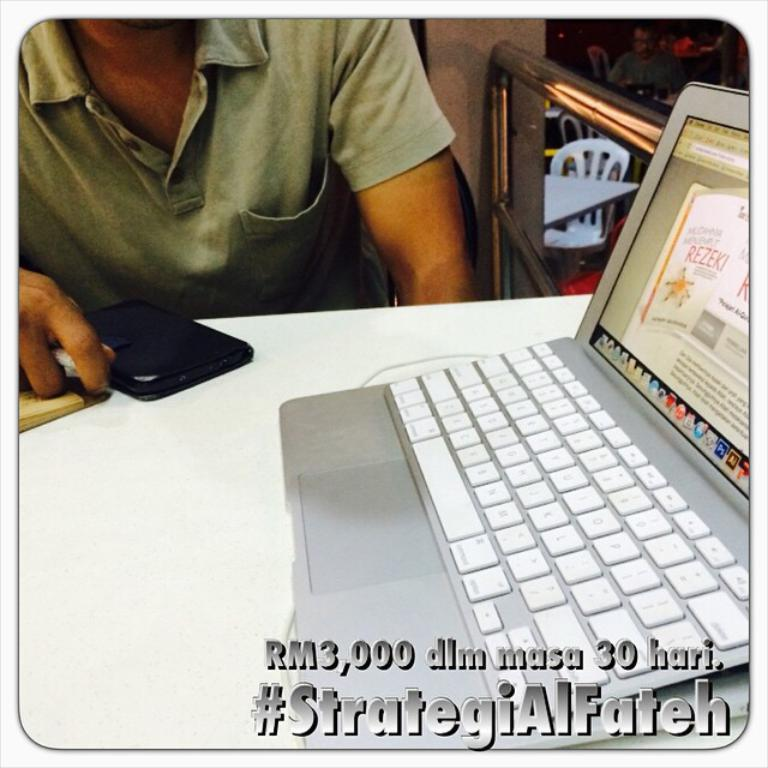<image>
Render a clear and concise summary of the photo. a silver macbook laptop with a page open that says rezeki on it 